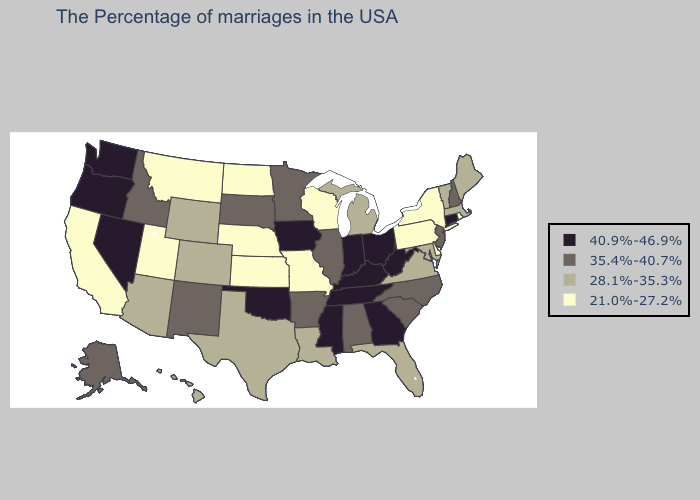Does Connecticut have the lowest value in the Northeast?
Write a very short answer. No. Does the map have missing data?
Concise answer only. No. Among the states that border Virginia , does North Carolina have the highest value?
Answer briefly. No. What is the lowest value in the USA?
Keep it brief. 21.0%-27.2%. Does Georgia have the lowest value in the South?
Short answer required. No. Does the first symbol in the legend represent the smallest category?
Give a very brief answer. No. Name the states that have a value in the range 21.0%-27.2%?
Be succinct. Rhode Island, New York, Delaware, Pennsylvania, Wisconsin, Missouri, Kansas, Nebraska, North Dakota, Utah, Montana, California. Which states have the lowest value in the USA?
Give a very brief answer. Rhode Island, New York, Delaware, Pennsylvania, Wisconsin, Missouri, Kansas, Nebraska, North Dakota, Utah, Montana, California. Which states have the lowest value in the USA?
Be succinct. Rhode Island, New York, Delaware, Pennsylvania, Wisconsin, Missouri, Kansas, Nebraska, North Dakota, Utah, Montana, California. What is the lowest value in the Northeast?
Write a very short answer. 21.0%-27.2%. Which states have the highest value in the USA?
Short answer required. Connecticut, West Virginia, Ohio, Georgia, Kentucky, Indiana, Tennessee, Mississippi, Iowa, Oklahoma, Nevada, Washington, Oregon. Does Mississippi have the highest value in the USA?
Write a very short answer. Yes. How many symbols are there in the legend?
Answer briefly. 4. What is the value of Wisconsin?
Short answer required. 21.0%-27.2%. What is the lowest value in the West?
Give a very brief answer. 21.0%-27.2%. 